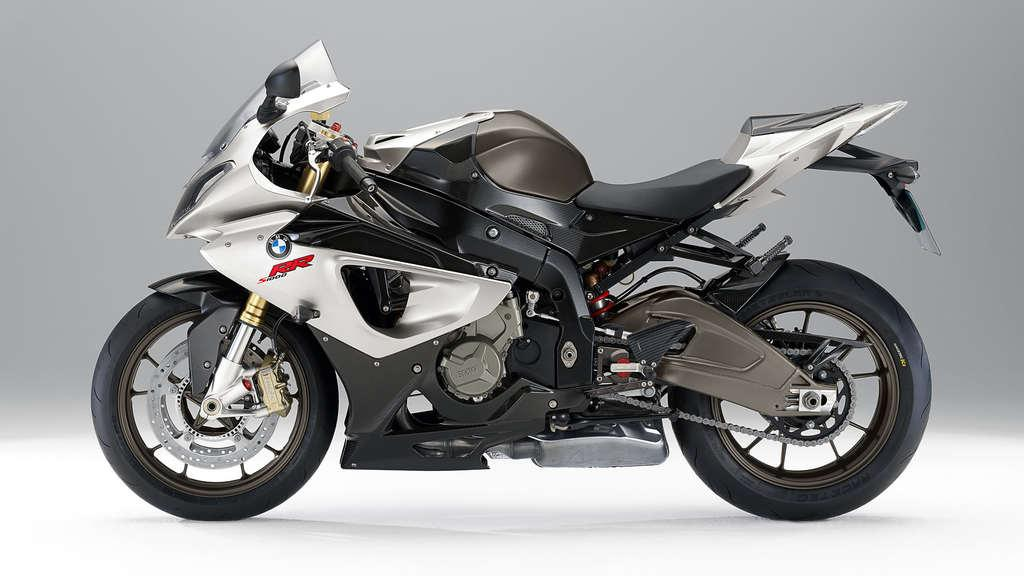What is the main subject of the image? The main subject of the image is a motorcycle. What is the color of the surface on which the motorcycle is placed? The motorcycle is on a white color surface. What type of beef is being cooked on the motorcycle in the image? There is no beef or cooking activity present in the image; it only features a motorcycle on a white surface. 